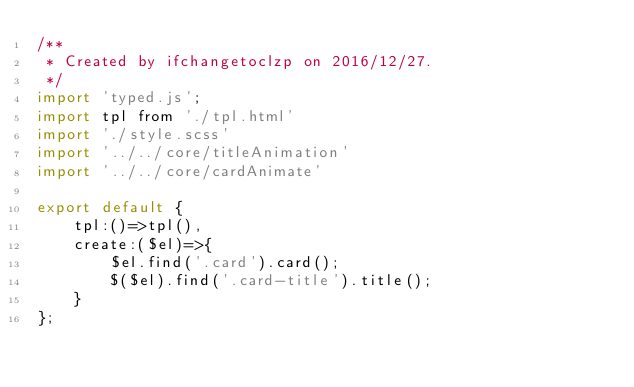Convert code to text. <code><loc_0><loc_0><loc_500><loc_500><_JavaScript_>/**
 * Created by ifchangetoclzp on 2016/12/27.
 */
import 'typed.js';
import tpl from './tpl.html'
import './style.scss'
import '../../core/titleAnimation'
import '../../core/cardAnimate'

export default {
    tpl:()=>tpl(),
    create:($el)=>{
        $el.find('.card').card();
        $($el).find('.card-title').title();
    }
};</code> 